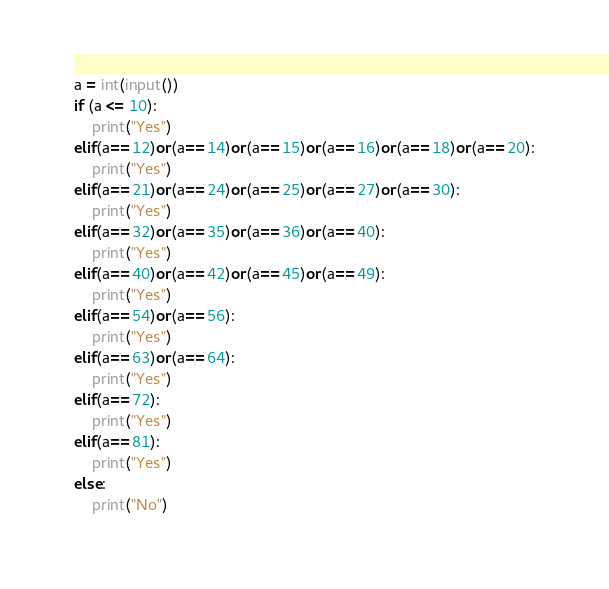Convert code to text. <code><loc_0><loc_0><loc_500><loc_500><_Python_>a = int(input())
if (a <= 10):
    print("Yes")
elif(a==12)or(a==14)or(a==15)or(a==16)or(a==18)or(a==20):
    print("Yes")
elif(a==21)or(a==24)or(a==25)or(a==27)or(a==30):
    print("Yes")
elif(a==32)or(a==35)or(a==36)or(a==40):
    print("Yes")
elif(a==40)or(a==42)or(a==45)or(a==49):
    print("Yes")
elif(a==54)or(a==56):
    print("Yes")
elif(a==63)or(a==64):
    print("Yes")
elif(a==72):
    print("Yes")
elif(a==81):
    print("Yes")
else:
    print("No")</code> 